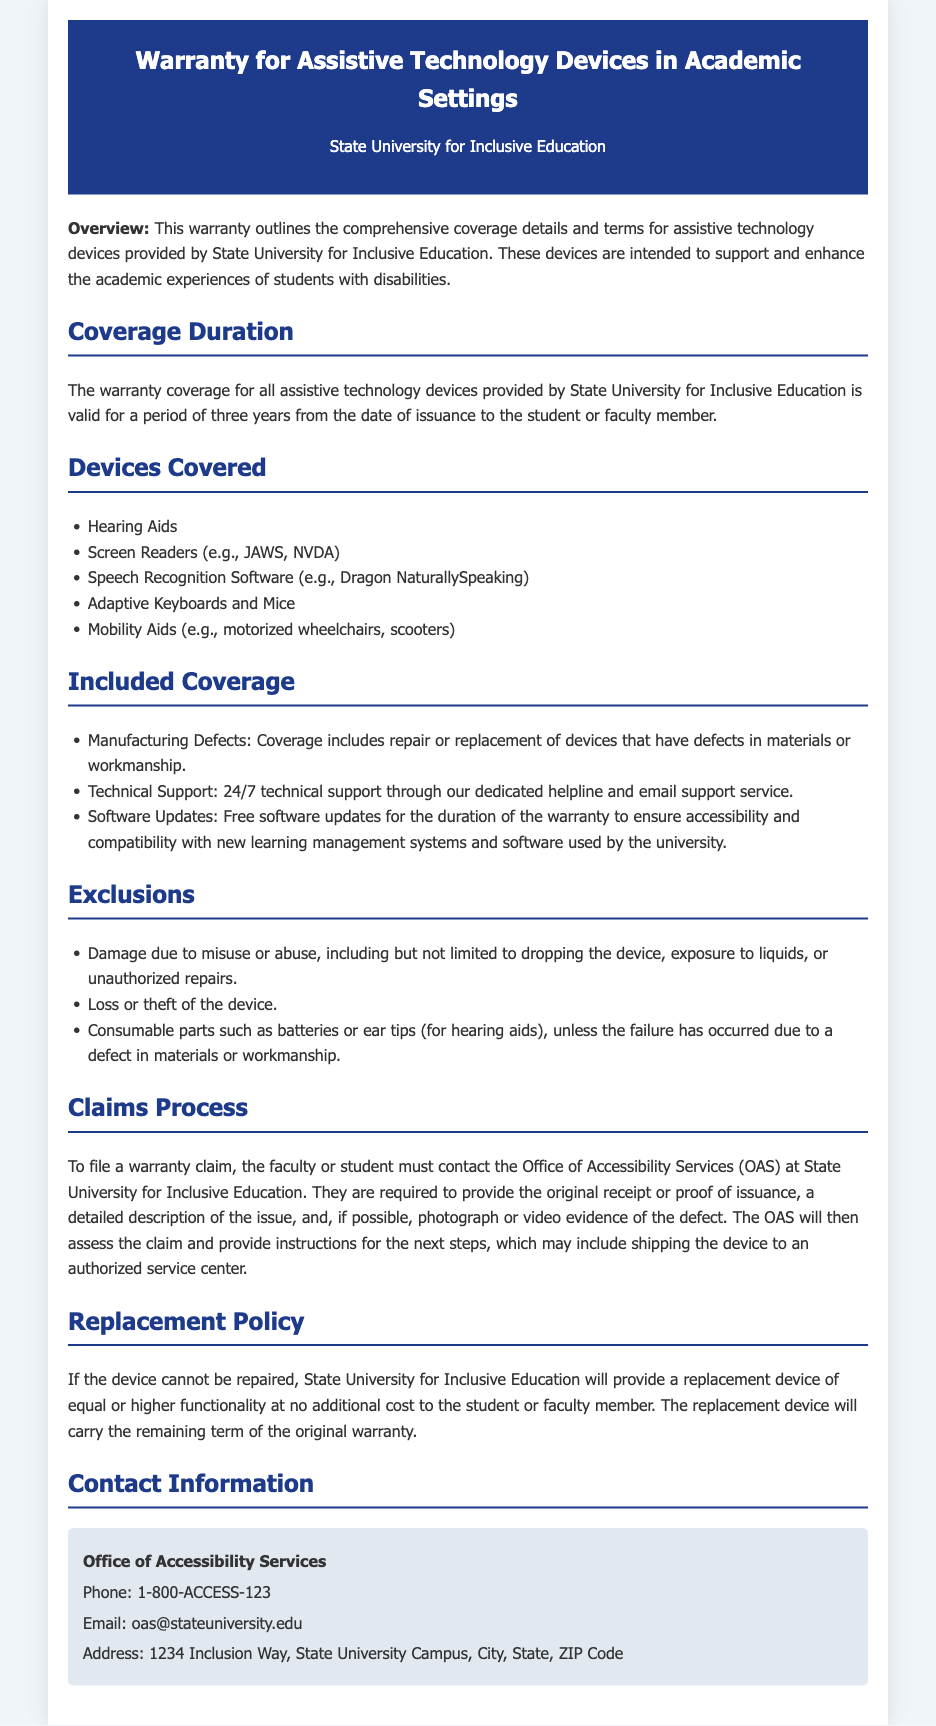What is the coverage duration for assistive technology devices? The warranty coverage for assistive technology devices is valid for a period of three years from the date of issuance.
Answer: three years Which devices are covered under this warranty? The warranty includes specific assistive technology devices listed in the document. Covered devices include hearing aids, screen readers, and others.
Answer: Hearing Aids, Screen Readers, Speech Recognition Software, Adaptive Keyboards and Mice, Mobility Aids What types of defects does the warranty cover? The warranty coverage includes repair or replacement of devices that have defects in materials or workmanship.
Answer: manufacturing defects What is excluded from the warranty? The document lists specific exclusions from the warranty coverage. Notably, misuse or abuse of the device results in exclusion.
Answer: Damage due to misuse or abuse How can a warranty claim be filed? To file a warranty claim, one must contact the Office of Accessibility Services and provide specific documentation.
Answer: Contact the Office of Accessibility Services What happens if the device cannot be repaired? The warranty has a provision for replacement if the device cannot be repaired.
Answer: replacement device of equal or higher functionality What support is provided during the warranty period? The warranty outlines the support services available throughout the coverage duration, including technical support.
Answer: 24/7 technical support Where can questions be directed regarding the warranty? The document specifies contact information for the Office of Accessibility Services where inquiries can be directed.
Answer: Office of Accessibility Services 